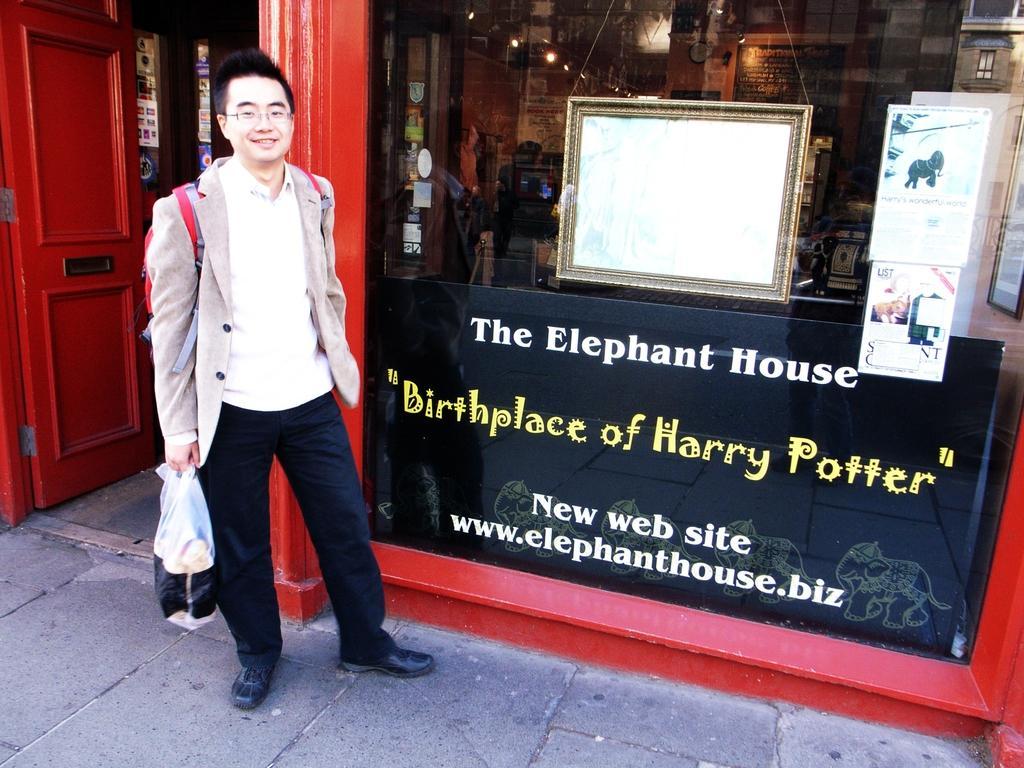In one or two sentences, can you explain what this image depicts? In this picture we can see a person holding a cover and wearing a bag. He is standing and smiling. There are few posters. We can see a building. There is a door. We can see some lights and other things in this building. 